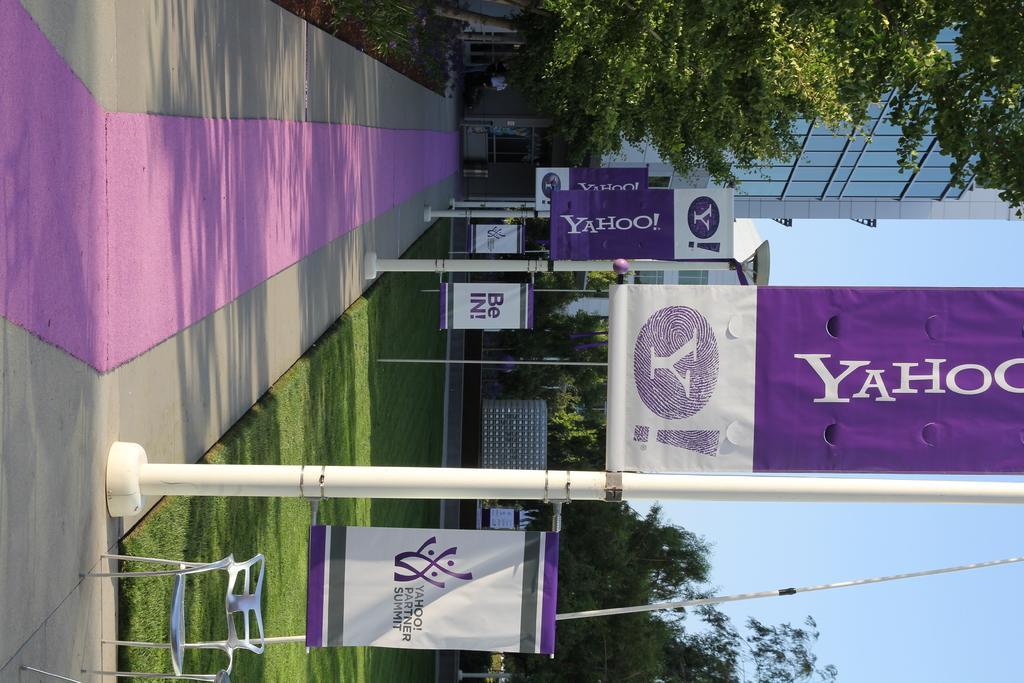How would you summarize this image in a sentence or two? In this image we can see some banners to the poles with some text on them. We can also see a chair on the ground, some grass, a pathway, poles, some plants, a group of trees, a building and the sky which looks cloudy. 